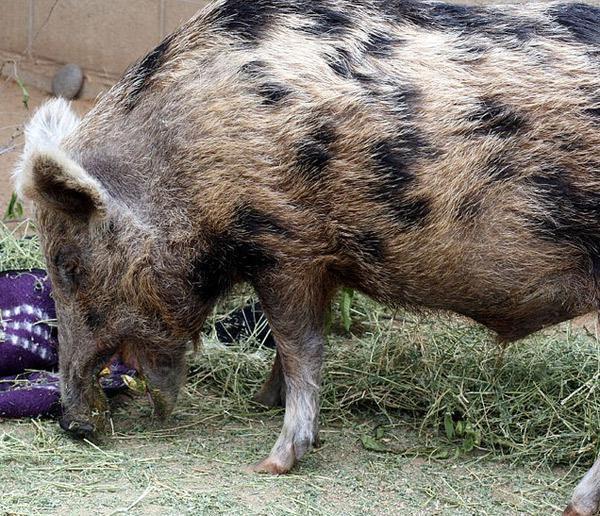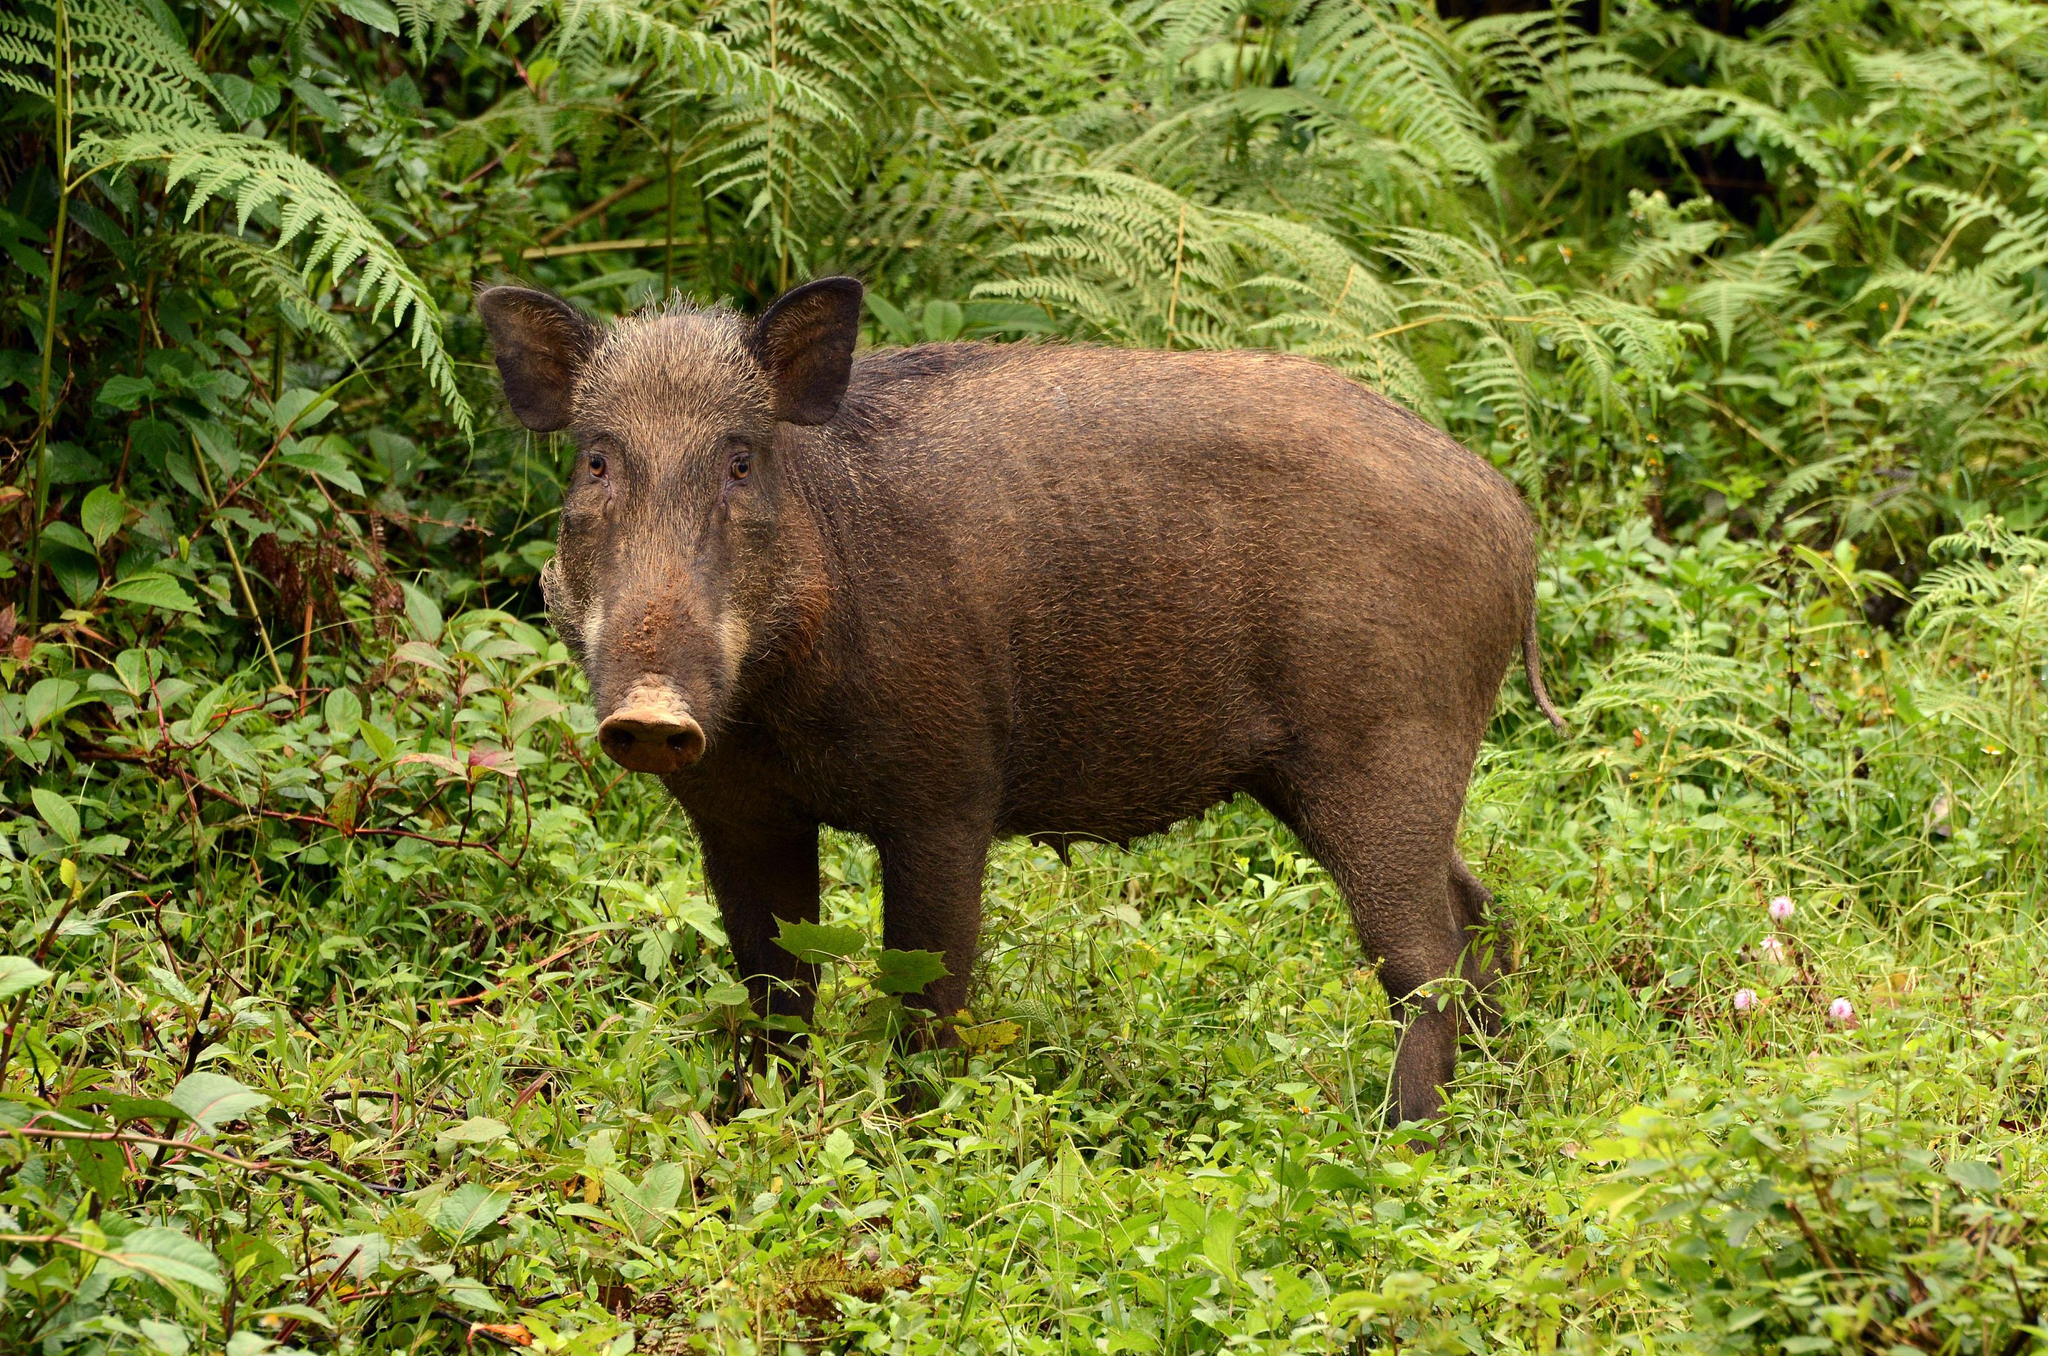The first image is the image on the left, the second image is the image on the right. Assess this claim about the two images: "There are at most two wild boars". Correct or not? Answer yes or no. Yes. 